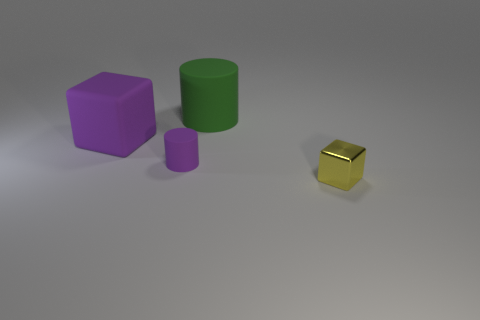Add 4 purple cylinders. How many objects exist? 8 Subtract 0 blue spheres. How many objects are left? 4 Subtract all yellow metallic things. Subtract all big green rubber cubes. How many objects are left? 3 Add 2 small yellow metal blocks. How many small yellow metal blocks are left? 3 Add 2 big green cylinders. How many big green cylinders exist? 3 